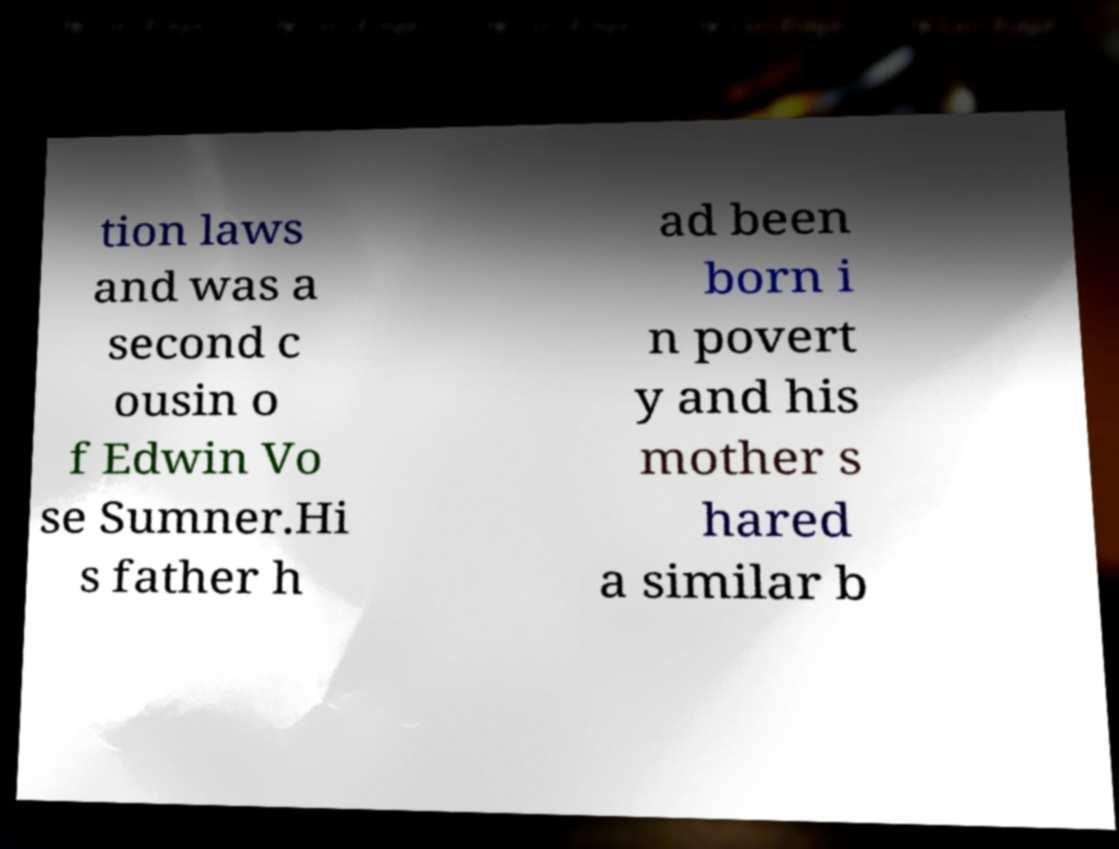I need the written content from this picture converted into text. Can you do that? tion laws and was a second c ousin o f Edwin Vo se Sumner.Hi s father h ad been born i n povert y and his mother s hared a similar b 